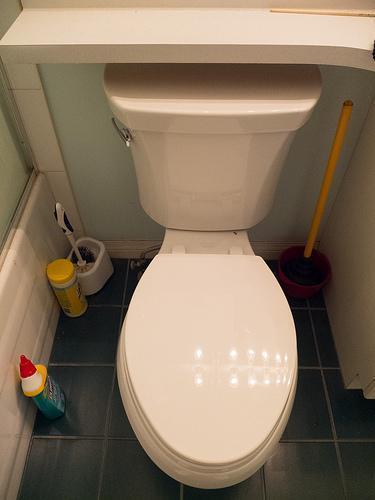How many toilets are shown?
Give a very brief answer. 1. 